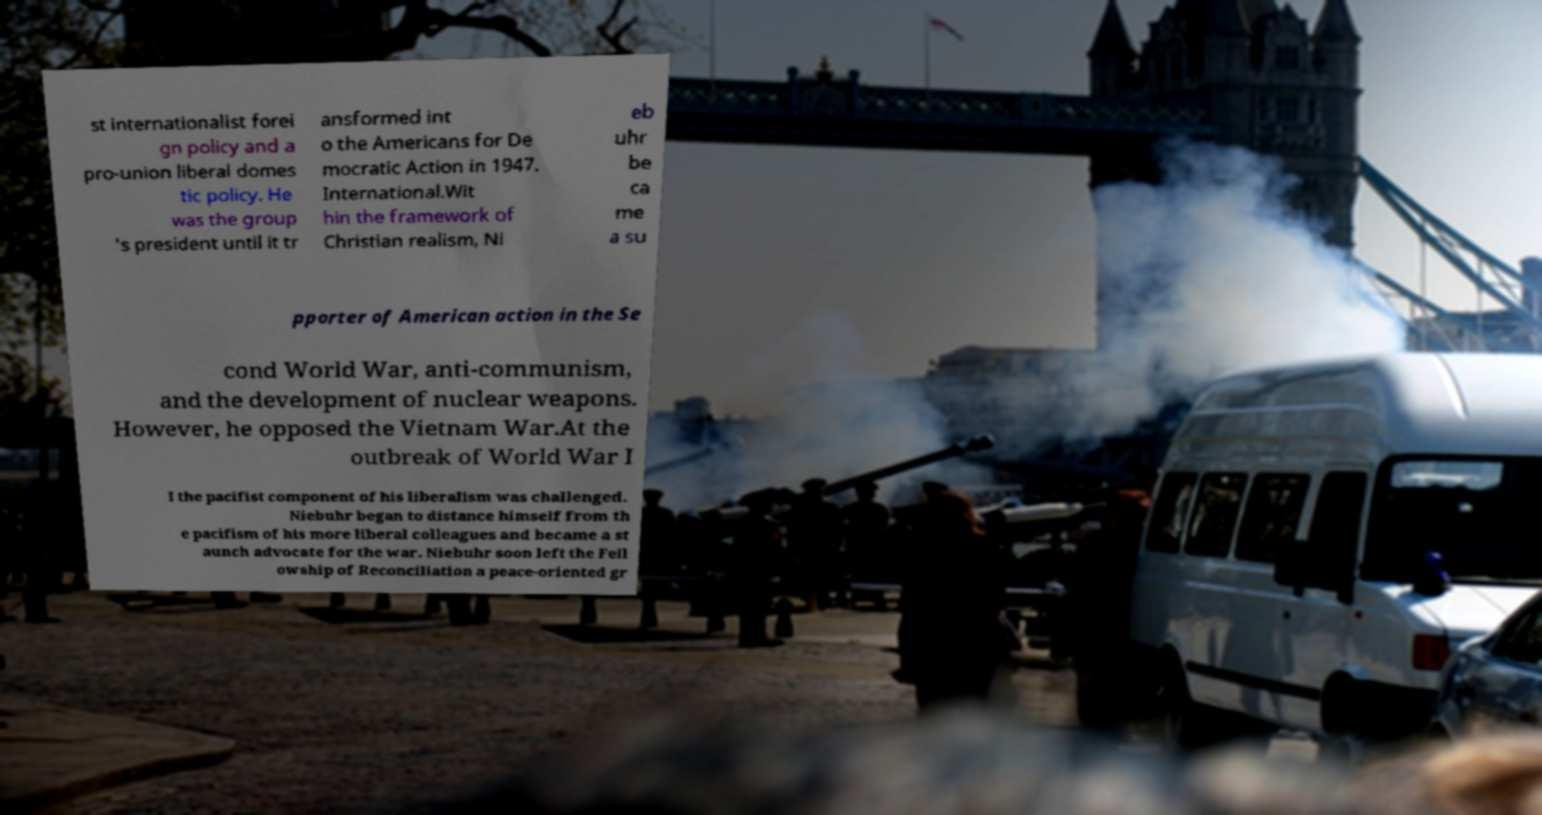What messages or text are displayed in this image? I need them in a readable, typed format. st internationalist forei gn policy and a pro-union liberal domes tic policy. He was the group 's president until it tr ansformed int o the Americans for De mocratic Action in 1947. International.Wit hin the framework of Christian realism, Ni eb uhr be ca me a su pporter of American action in the Se cond World War, anti-communism, and the development of nuclear weapons. However, he opposed the Vietnam War.At the outbreak of World War I I the pacifist component of his liberalism was challenged. Niebuhr began to distance himself from th e pacifism of his more liberal colleagues and became a st aunch advocate for the war. Niebuhr soon left the Fell owship of Reconciliation a peace-oriented gr 